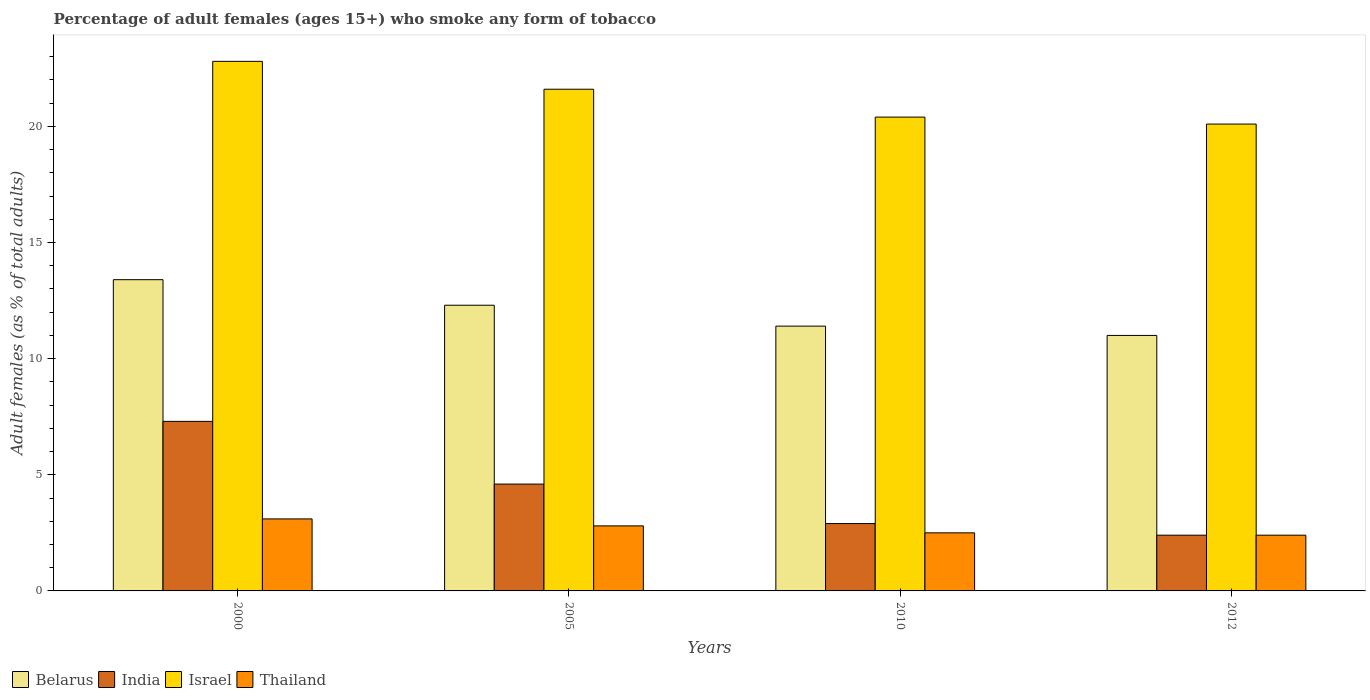Are the number of bars per tick equal to the number of legend labels?
Your answer should be very brief. Yes. Are the number of bars on each tick of the X-axis equal?
Make the answer very short. Yes. In how many cases, is the number of bars for a given year not equal to the number of legend labels?
Your response must be concise. 0. Across all years, what is the maximum percentage of adult females who smoke in India?
Keep it short and to the point. 7.3. Across all years, what is the minimum percentage of adult females who smoke in India?
Provide a succinct answer. 2.4. In which year was the percentage of adult females who smoke in Thailand minimum?
Provide a succinct answer. 2012. What is the total percentage of adult females who smoke in Belarus in the graph?
Provide a short and direct response. 48.1. What is the difference between the percentage of adult females who smoke in India in 2000 and that in 2012?
Provide a succinct answer. 4.9. In the year 2000, what is the difference between the percentage of adult females who smoke in India and percentage of adult females who smoke in Belarus?
Your response must be concise. -6.1. What is the ratio of the percentage of adult females who smoke in Thailand in 2010 to that in 2012?
Keep it short and to the point. 1.04. Is the difference between the percentage of adult females who smoke in India in 2005 and 2012 greater than the difference between the percentage of adult females who smoke in Belarus in 2005 and 2012?
Provide a short and direct response. Yes. What is the difference between the highest and the second highest percentage of adult females who smoke in India?
Offer a terse response. 2.7. In how many years, is the percentage of adult females who smoke in India greater than the average percentage of adult females who smoke in India taken over all years?
Give a very brief answer. 2. Is the sum of the percentage of adult females who smoke in Thailand in 2005 and 2012 greater than the maximum percentage of adult females who smoke in Israel across all years?
Keep it short and to the point. No. Is it the case that in every year, the sum of the percentage of adult females who smoke in Thailand and percentage of adult females who smoke in India is greater than the sum of percentage of adult females who smoke in Belarus and percentage of adult females who smoke in Israel?
Offer a terse response. No. What does the 1st bar from the left in 2005 represents?
Ensure brevity in your answer.  Belarus. What does the 2nd bar from the right in 2000 represents?
Ensure brevity in your answer.  Israel. Is it the case that in every year, the sum of the percentage of adult females who smoke in India and percentage of adult females who smoke in Belarus is greater than the percentage of adult females who smoke in Thailand?
Make the answer very short. Yes. How many bars are there?
Provide a short and direct response. 16. What is the difference between two consecutive major ticks on the Y-axis?
Your response must be concise. 5. Are the values on the major ticks of Y-axis written in scientific E-notation?
Your answer should be compact. No. Does the graph contain grids?
Ensure brevity in your answer.  No. Where does the legend appear in the graph?
Your response must be concise. Bottom left. How are the legend labels stacked?
Give a very brief answer. Horizontal. What is the title of the graph?
Offer a very short reply. Percentage of adult females (ages 15+) who smoke any form of tobacco. Does "St. Lucia" appear as one of the legend labels in the graph?
Provide a succinct answer. No. What is the label or title of the Y-axis?
Give a very brief answer. Adult females (as % of total adults). What is the Adult females (as % of total adults) of Israel in 2000?
Ensure brevity in your answer.  22.8. What is the Adult females (as % of total adults) in Thailand in 2000?
Your answer should be compact. 3.1. What is the Adult females (as % of total adults) in Belarus in 2005?
Ensure brevity in your answer.  12.3. What is the Adult females (as % of total adults) in India in 2005?
Give a very brief answer. 4.6. What is the Adult females (as % of total adults) of Israel in 2005?
Make the answer very short. 21.6. What is the Adult females (as % of total adults) of Israel in 2010?
Keep it short and to the point. 20.4. What is the Adult females (as % of total adults) of Thailand in 2010?
Provide a succinct answer. 2.5. What is the Adult females (as % of total adults) in Israel in 2012?
Offer a very short reply. 20.1. What is the Adult females (as % of total adults) of Thailand in 2012?
Offer a terse response. 2.4. Across all years, what is the maximum Adult females (as % of total adults) in India?
Your answer should be very brief. 7.3. Across all years, what is the maximum Adult females (as % of total adults) in Israel?
Make the answer very short. 22.8. Across all years, what is the maximum Adult females (as % of total adults) of Thailand?
Keep it short and to the point. 3.1. Across all years, what is the minimum Adult females (as % of total adults) in Belarus?
Your response must be concise. 11. Across all years, what is the minimum Adult females (as % of total adults) in Israel?
Provide a succinct answer. 20.1. What is the total Adult females (as % of total adults) in Belarus in the graph?
Your answer should be very brief. 48.1. What is the total Adult females (as % of total adults) of Israel in the graph?
Provide a succinct answer. 84.9. What is the difference between the Adult females (as % of total adults) in India in 2000 and that in 2005?
Provide a succinct answer. 2.7. What is the difference between the Adult females (as % of total adults) in Thailand in 2000 and that in 2005?
Make the answer very short. 0.3. What is the difference between the Adult females (as % of total adults) of Belarus in 2000 and that in 2010?
Offer a terse response. 2. What is the difference between the Adult females (as % of total adults) in Thailand in 2000 and that in 2010?
Your response must be concise. 0.6. What is the difference between the Adult females (as % of total adults) in India in 2000 and that in 2012?
Your response must be concise. 4.9. What is the difference between the Adult females (as % of total adults) of Israel in 2000 and that in 2012?
Make the answer very short. 2.7. What is the difference between the Adult females (as % of total adults) in India in 2005 and that in 2010?
Make the answer very short. 1.7. What is the difference between the Adult females (as % of total adults) of India in 2005 and that in 2012?
Your response must be concise. 2.2. What is the difference between the Adult females (as % of total adults) in Israel in 2005 and that in 2012?
Keep it short and to the point. 1.5. What is the difference between the Adult females (as % of total adults) in India in 2010 and that in 2012?
Offer a very short reply. 0.5. What is the difference between the Adult females (as % of total adults) of Israel in 2010 and that in 2012?
Provide a succinct answer. 0.3. What is the difference between the Adult females (as % of total adults) in Belarus in 2000 and the Adult females (as % of total adults) in India in 2005?
Provide a short and direct response. 8.8. What is the difference between the Adult females (as % of total adults) of Belarus in 2000 and the Adult females (as % of total adults) of Thailand in 2005?
Provide a succinct answer. 10.6. What is the difference between the Adult females (as % of total adults) in India in 2000 and the Adult females (as % of total adults) in Israel in 2005?
Offer a terse response. -14.3. What is the difference between the Adult females (as % of total adults) in India in 2000 and the Adult females (as % of total adults) in Thailand in 2005?
Provide a succinct answer. 4.5. What is the difference between the Adult females (as % of total adults) in Israel in 2000 and the Adult females (as % of total adults) in Thailand in 2005?
Provide a succinct answer. 20. What is the difference between the Adult females (as % of total adults) of India in 2000 and the Adult females (as % of total adults) of Thailand in 2010?
Offer a very short reply. 4.8. What is the difference between the Adult females (as % of total adults) in Israel in 2000 and the Adult females (as % of total adults) in Thailand in 2010?
Offer a very short reply. 20.3. What is the difference between the Adult females (as % of total adults) in Belarus in 2000 and the Adult females (as % of total adults) in Israel in 2012?
Give a very brief answer. -6.7. What is the difference between the Adult females (as % of total adults) of Israel in 2000 and the Adult females (as % of total adults) of Thailand in 2012?
Offer a very short reply. 20.4. What is the difference between the Adult females (as % of total adults) in India in 2005 and the Adult females (as % of total adults) in Israel in 2010?
Offer a terse response. -15.8. What is the difference between the Adult females (as % of total adults) in India in 2005 and the Adult females (as % of total adults) in Thailand in 2010?
Provide a succinct answer. 2.1. What is the difference between the Adult females (as % of total adults) in Belarus in 2005 and the Adult females (as % of total adults) in India in 2012?
Offer a very short reply. 9.9. What is the difference between the Adult females (as % of total adults) of Belarus in 2005 and the Adult females (as % of total adults) of Thailand in 2012?
Keep it short and to the point. 9.9. What is the difference between the Adult females (as % of total adults) of India in 2005 and the Adult females (as % of total adults) of Israel in 2012?
Your answer should be compact. -15.5. What is the difference between the Adult females (as % of total adults) in India in 2005 and the Adult females (as % of total adults) in Thailand in 2012?
Your answer should be very brief. 2.2. What is the difference between the Adult females (as % of total adults) of Belarus in 2010 and the Adult females (as % of total adults) of Thailand in 2012?
Your response must be concise. 9. What is the difference between the Adult females (as % of total adults) of India in 2010 and the Adult females (as % of total adults) of Israel in 2012?
Keep it short and to the point. -17.2. What is the difference between the Adult females (as % of total adults) of India in 2010 and the Adult females (as % of total adults) of Thailand in 2012?
Make the answer very short. 0.5. What is the difference between the Adult females (as % of total adults) of Israel in 2010 and the Adult females (as % of total adults) of Thailand in 2012?
Ensure brevity in your answer.  18. What is the average Adult females (as % of total adults) in Belarus per year?
Offer a very short reply. 12.03. What is the average Adult females (as % of total adults) of India per year?
Ensure brevity in your answer.  4.3. What is the average Adult females (as % of total adults) of Israel per year?
Offer a terse response. 21.23. In the year 2000, what is the difference between the Adult females (as % of total adults) in Belarus and Adult females (as % of total adults) in Israel?
Offer a terse response. -9.4. In the year 2000, what is the difference between the Adult females (as % of total adults) in Belarus and Adult females (as % of total adults) in Thailand?
Provide a short and direct response. 10.3. In the year 2000, what is the difference between the Adult females (as % of total adults) of India and Adult females (as % of total adults) of Israel?
Provide a short and direct response. -15.5. In the year 2005, what is the difference between the Adult females (as % of total adults) of India and Adult females (as % of total adults) of Israel?
Offer a very short reply. -17. In the year 2005, what is the difference between the Adult females (as % of total adults) in Israel and Adult females (as % of total adults) in Thailand?
Give a very brief answer. 18.8. In the year 2010, what is the difference between the Adult females (as % of total adults) in Belarus and Adult females (as % of total adults) in Israel?
Give a very brief answer. -9. In the year 2010, what is the difference between the Adult females (as % of total adults) in Belarus and Adult females (as % of total adults) in Thailand?
Your answer should be very brief. 8.9. In the year 2010, what is the difference between the Adult females (as % of total adults) in India and Adult females (as % of total adults) in Israel?
Offer a terse response. -17.5. In the year 2010, what is the difference between the Adult females (as % of total adults) of Israel and Adult females (as % of total adults) of Thailand?
Your answer should be compact. 17.9. In the year 2012, what is the difference between the Adult females (as % of total adults) of Belarus and Adult females (as % of total adults) of India?
Offer a terse response. 8.6. In the year 2012, what is the difference between the Adult females (as % of total adults) of India and Adult females (as % of total adults) of Israel?
Give a very brief answer. -17.7. In the year 2012, what is the difference between the Adult females (as % of total adults) of India and Adult females (as % of total adults) of Thailand?
Your answer should be very brief. 0. What is the ratio of the Adult females (as % of total adults) in Belarus in 2000 to that in 2005?
Your answer should be very brief. 1.09. What is the ratio of the Adult females (as % of total adults) in India in 2000 to that in 2005?
Give a very brief answer. 1.59. What is the ratio of the Adult females (as % of total adults) of Israel in 2000 to that in 2005?
Keep it short and to the point. 1.06. What is the ratio of the Adult females (as % of total adults) of Thailand in 2000 to that in 2005?
Your answer should be compact. 1.11. What is the ratio of the Adult females (as % of total adults) of Belarus in 2000 to that in 2010?
Your answer should be compact. 1.18. What is the ratio of the Adult females (as % of total adults) in India in 2000 to that in 2010?
Keep it short and to the point. 2.52. What is the ratio of the Adult females (as % of total adults) in Israel in 2000 to that in 2010?
Ensure brevity in your answer.  1.12. What is the ratio of the Adult females (as % of total adults) in Thailand in 2000 to that in 2010?
Offer a terse response. 1.24. What is the ratio of the Adult females (as % of total adults) of Belarus in 2000 to that in 2012?
Offer a very short reply. 1.22. What is the ratio of the Adult females (as % of total adults) of India in 2000 to that in 2012?
Provide a succinct answer. 3.04. What is the ratio of the Adult females (as % of total adults) of Israel in 2000 to that in 2012?
Provide a short and direct response. 1.13. What is the ratio of the Adult females (as % of total adults) in Thailand in 2000 to that in 2012?
Make the answer very short. 1.29. What is the ratio of the Adult females (as % of total adults) of Belarus in 2005 to that in 2010?
Your answer should be compact. 1.08. What is the ratio of the Adult females (as % of total adults) of India in 2005 to that in 2010?
Provide a succinct answer. 1.59. What is the ratio of the Adult females (as % of total adults) of Israel in 2005 to that in 2010?
Offer a terse response. 1.06. What is the ratio of the Adult females (as % of total adults) in Thailand in 2005 to that in 2010?
Make the answer very short. 1.12. What is the ratio of the Adult females (as % of total adults) in Belarus in 2005 to that in 2012?
Keep it short and to the point. 1.12. What is the ratio of the Adult females (as % of total adults) of India in 2005 to that in 2012?
Provide a succinct answer. 1.92. What is the ratio of the Adult females (as % of total adults) in Israel in 2005 to that in 2012?
Provide a short and direct response. 1.07. What is the ratio of the Adult females (as % of total adults) in Thailand in 2005 to that in 2012?
Make the answer very short. 1.17. What is the ratio of the Adult females (as % of total adults) of Belarus in 2010 to that in 2012?
Your response must be concise. 1.04. What is the ratio of the Adult females (as % of total adults) in India in 2010 to that in 2012?
Offer a terse response. 1.21. What is the ratio of the Adult females (as % of total adults) of Israel in 2010 to that in 2012?
Your answer should be compact. 1.01. What is the ratio of the Adult females (as % of total adults) of Thailand in 2010 to that in 2012?
Ensure brevity in your answer.  1.04. What is the difference between the highest and the second highest Adult females (as % of total adults) in Belarus?
Provide a short and direct response. 1.1. What is the difference between the highest and the second highest Adult females (as % of total adults) in Israel?
Your answer should be very brief. 1.2. What is the difference between the highest and the second highest Adult females (as % of total adults) of Thailand?
Your answer should be compact. 0.3. What is the difference between the highest and the lowest Adult females (as % of total adults) in Belarus?
Your answer should be compact. 2.4. What is the difference between the highest and the lowest Adult females (as % of total adults) of Thailand?
Give a very brief answer. 0.7. 